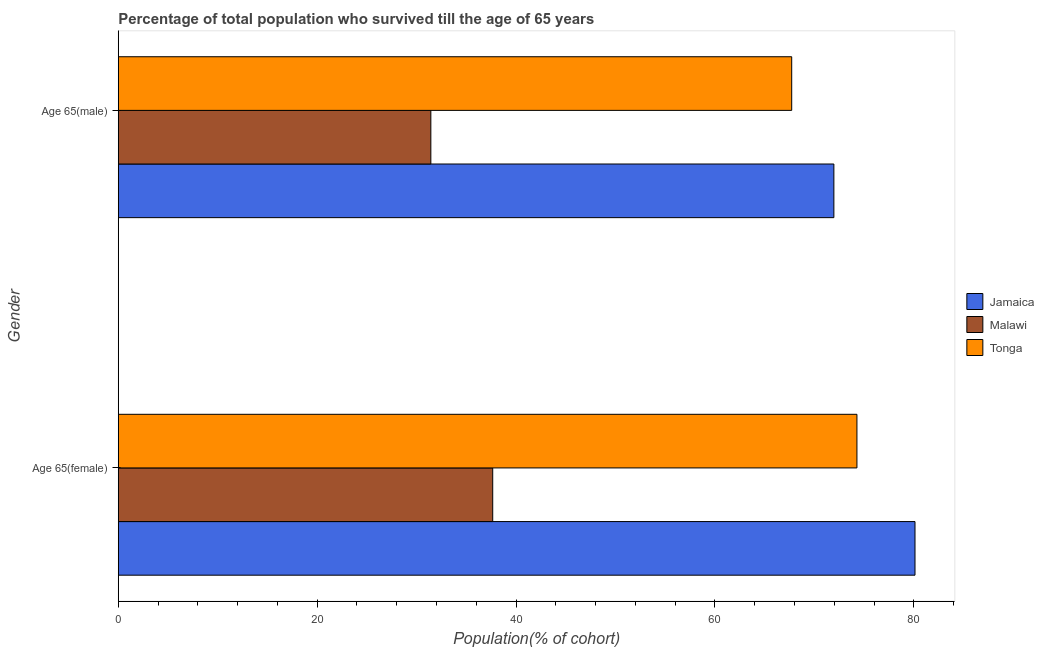How many different coloured bars are there?
Your answer should be compact. 3. How many groups of bars are there?
Offer a terse response. 2. Are the number of bars per tick equal to the number of legend labels?
Make the answer very short. Yes. What is the label of the 2nd group of bars from the top?
Offer a very short reply. Age 65(female). What is the percentage of female population who survived till age of 65 in Tonga?
Provide a short and direct response. 74.27. Across all countries, what is the maximum percentage of female population who survived till age of 65?
Make the answer very short. 80.11. Across all countries, what is the minimum percentage of female population who survived till age of 65?
Keep it short and to the point. 37.65. In which country was the percentage of female population who survived till age of 65 maximum?
Make the answer very short. Jamaica. In which country was the percentage of male population who survived till age of 65 minimum?
Your response must be concise. Malawi. What is the total percentage of female population who survived till age of 65 in the graph?
Offer a terse response. 192.03. What is the difference between the percentage of female population who survived till age of 65 in Jamaica and that in Malawi?
Ensure brevity in your answer.  42.46. What is the difference between the percentage of female population who survived till age of 65 in Malawi and the percentage of male population who survived till age of 65 in Tonga?
Provide a succinct answer. -30.06. What is the average percentage of male population who survived till age of 65 per country?
Make the answer very short. 57.03. What is the difference between the percentage of male population who survived till age of 65 and percentage of female population who survived till age of 65 in Tonga?
Your response must be concise. -6.56. In how many countries, is the percentage of male population who survived till age of 65 greater than 32 %?
Keep it short and to the point. 2. What is the ratio of the percentage of female population who survived till age of 65 in Jamaica to that in Tonga?
Provide a succinct answer. 1.08. What does the 3rd bar from the top in Age 65(female) represents?
Provide a succinct answer. Jamaica. What does the 1st bar from the bottom in Age 65(female) represents?
Ensure brevity in your answer.  Jamaica. Are all the bars in the graph horizontal?
Keep it short and to the point. Yes. What is the difference between two consecutive major ticks on the X-axis?
Provide a succinct answer. 20. Are the values on the major ticks of X-axis written in scientific E-notation?
Make the answer very short. No. Does the graph contain any zero values?
Keep it short and to the point. No. How are the legend labels stacked?
Keep it short and to the point. Vertical. What is the title of the graph?
Provide a succinct answer. Percentage of total population who survived till the age of 65 years. What is the label or title of the X-axis?
Your answer should be very brief. Population(% of cohort). What is the label or title of the Y-axis?
Provide a short and direct response. Gender. What is the Population(% of cohort) of Jamaica in Age 65(female)?
Provide a short and direct response. 80.11. What is the Population(% of cohort) of Malawi in Age 65(female)?
Provide a short and direct response. 37.65. What is the Population(% of cohort) of Tonga in Age 65(female)?
Your answer should be compact. 74.27. What is the Population(% of cohort) of Jamaica in Age 65(male)?
Offer a very short reply. 71.95. What is the Population(% of cohort) of Malawi in Age 65(male)?
Your answer should be very brief. 31.43. What is the Population(% of cohort) in Tonga in Age 65(male)?
Provide a short and direct response. 67.71. Across all Gender, what is the maximum Population(% of cohort) of Jamaica?
Your response must be concise. 80.11. Across all Gender, what is the maximum Population(% of cohort) in Malawi?
Your response must be concise. 37.65. Across all Gender, what is the maximum Population(% of cohort) of Tonga?
Ensure brevity in your answer.  74.27. Across all Gender, what is the minimum Population(% of cohort) of Jamaica?
Provide a short and direct response. 71.95. Across all Gender, what is the minimum Population(% of cohort) in Malawi?
Provide a short and direct response. 31.43. Across all Gender, what is the minimum Population(% of cohort) in Tonga?
Provide a succinct answer. 67.71. What is the total Population(% of cohort) of Jamaica in the graph?
Provide a short and direct response. 152.07. What is the total Population(% of cohort) in Malawi in the graph?
Your answer should be very brief. 69.08. What is the total Population(% of cohort) of Tonga in the graph?
Offer a terse response. 141.99. What is the difference between the Population(% of cohort) of Jamaica in Age 65(female) and that in Age 65(male)?
Give a very brief answer. 8.16. What is the difference between the Population(% of cohort) of Malawi in Age 65(female) and that in Age 65(male)?
Offer a very short reply. 6.22. What is the difference between the Population(% of cohort) of Tonga in Age 65(female) and that in Age 65(male)?
Your answer should be very brief. 6.56. What is the difference between the Population(% of cohort) of Jamaica in Age 65(female) and the Population(% of cohort) of Malawi in Age 65(male)?
Your answer should be compact. 48.68. What is the difference between the Population(% of cohort) of Jamaica in Age 65(female) and the Population(% of cohort) of Tonga in Age 65(male)?
Keep it short and to the point. 12.4. What is the difference between the Population(% of cohort) of Malawi in Age 65(female) and the Population(% of cohort) of Tonga in Age 65(male)?
Offer a very short reply. -30.06. What is the average Population(% of cohort) in Jamaica per Gender?
Provide a succinct answer. 76.03. What is the average Population(% of cohort) of Malawi per Gender?
Keep it short and to the point. 34.54. What is the average Population(% of cohort) in Tonga per Gender?
Your answer should be compact. 70.99. What is the difference between the Population(% of cohort) in Jamaica and Population(% of cohort) in Malawi in Age 65(female)?
Ensure brevity in your answer.  42.46. What is the difference between the Population(% of cohort) of Jamaica and Population(% of cohort) of Tonga in Age 65(female)?
Make the answer very short. 5.84. What is the difference between the Population(% of cohort) in Malawi and Population(% of cohort) in Tonga in Age 65(female)?
Offer a terse response. -36.62. What is the difference between the Population(% of cohort) of Jamaica and Population(% of cohort) of Malawi in Age 65(male)?
Provide a short and direct response. 40.53. What is the difference between the Population(% of cohort) in Jamaica and Population(% of cohort) in Tonga in Age 65(male)?
Keep it short and to the point. 4.24. What is the difference between the Population(% of cohort) of Malawi and Population(% of cohort) of Tonga in Age 65(male)?
Your answer should be very brief. -36.29. What is the ratio of the Population(% of cohort) of Jamaica in Age 65(female) to that in Age 65(male)?
Offer a terse response. 1.11. What is the ratio of the Population(% of cohort) of Malawi in Age 65(female) to that in Age 65(male)?
Your answer should be compact. 1.2. What is the ratio of the Population(% of cohort) in Tonga in Age 65(female) to that in Age 65(male)?
Offer a terse response. 1.1. What is the difference between the highest and the second highest Population(% of cohort) of Jamaica?
Make the answer very short. 8.16. What is the difference between the highest and the second highest Population(% of cohort) in Malawi?
Offer a terse response. 6.22. What is the difference between the highest and the second highest Population(% of cohort) of Tonga?
Ensure brevity in your answer.  6.56. What is the difference between the highest and the lowest Population(% of cohort) of Jamaica?
Give a very brief answer. 8.16. What is the difference between the highest and the lowest Population(% of cohort) in Malawi?
Ensure brevity in your answer.  6.22. What is the difference between the highest and the lowest Population(% of cohort) of Tonga?
Your response must be concise. 6.56. 